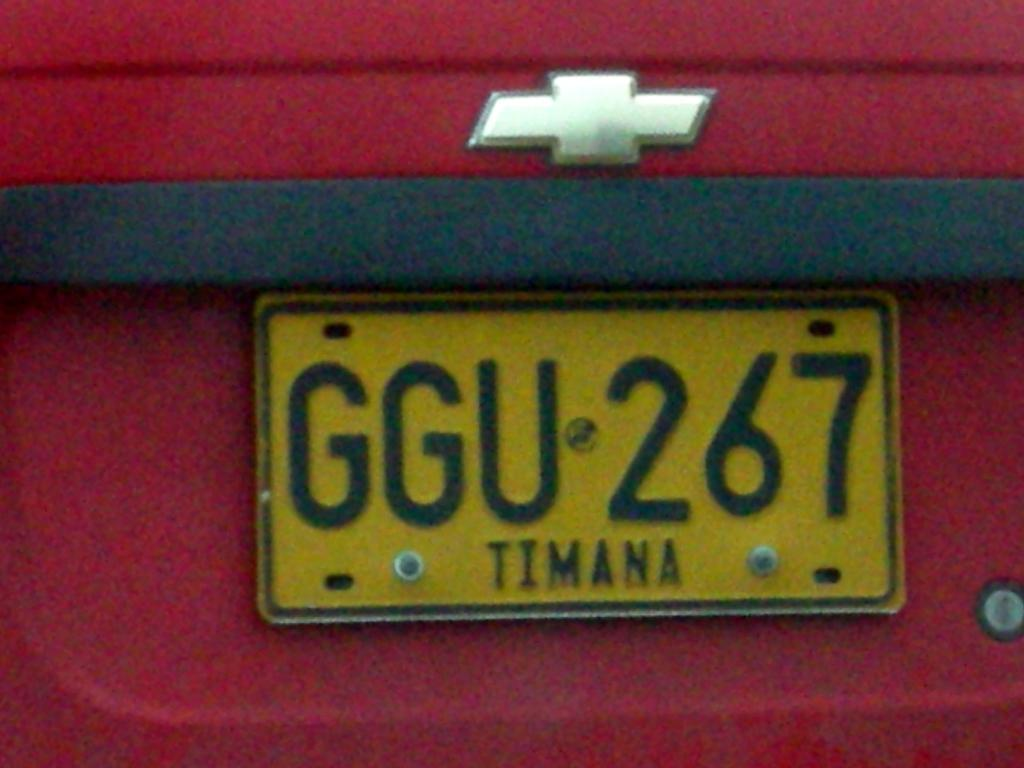<image>
Write a terse but informative summary of the picture. A license plate marked for an area called Timana is screwed into a red car. 